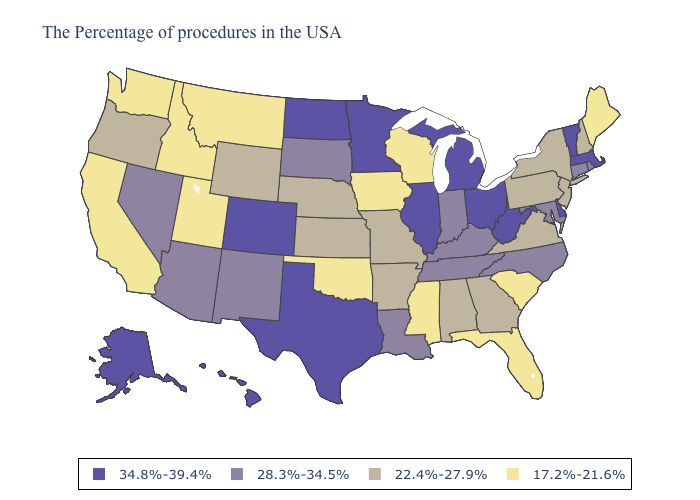Does Hawaii have a lower value than Arkansas?
Quick response, please. No. What is the lowest value in the USA?
Concise answer only. 17.2%-21.6%. What is the value of Michigan?
Quick response, please. 34.8%-39.4%. Which states hav the highest value in the South?
Short answer required. Delaware, West Virginia, Texas. Name the states that have a value in the range 28.3%-34.5%?
Keep it brief. Rhode Island, Connecticut, Maryland, North Carolina, Kentucky, Indiana, Tennessee, Louisiana, South Dakota, New Mexico, Arizona, Nevada. Among the states that border Nebraska , which have the lowest value?
Give a very brief answer. Iowa. What is the value of Illinois?
Quick response, please. 34.8%-39.4%. How many symbols are there in the legend?
Concise answer only. 4. Which states have the lowest value in the USA?
Answer briefly. Maine, South Carolina, Florida, Wisconsin, Mississippi, Iowa, Oklahoma, Utah, Montana, Idaho, California, Washington. Is the legend a continuous bar?
Concise answer only. No. Name the states that have a value in the range 34.8%-39.4%?
Quick response, please. Massachusetts, Vermont, Delaware, West Virginia, Ohio, Michigan, Illinois, Minnesota, Texas, North Dakota, Colorado, Alaska, Hawaii. Name the states that have a value in the range 22.4%-27.9%?
Keep it brief. New Hampshire, New York, New Jersey, Pennsylvania, Virginia, Georgia, Alabama, Missouri, Arkansas, Kansas, Nebraska, Wyoming, Oregon. What is the highest value in the Northeast ?
Write a very short answer. 34.8%-39.4%. Does Kansas have a lower value than Vermont?
Be succinct. Yes. 